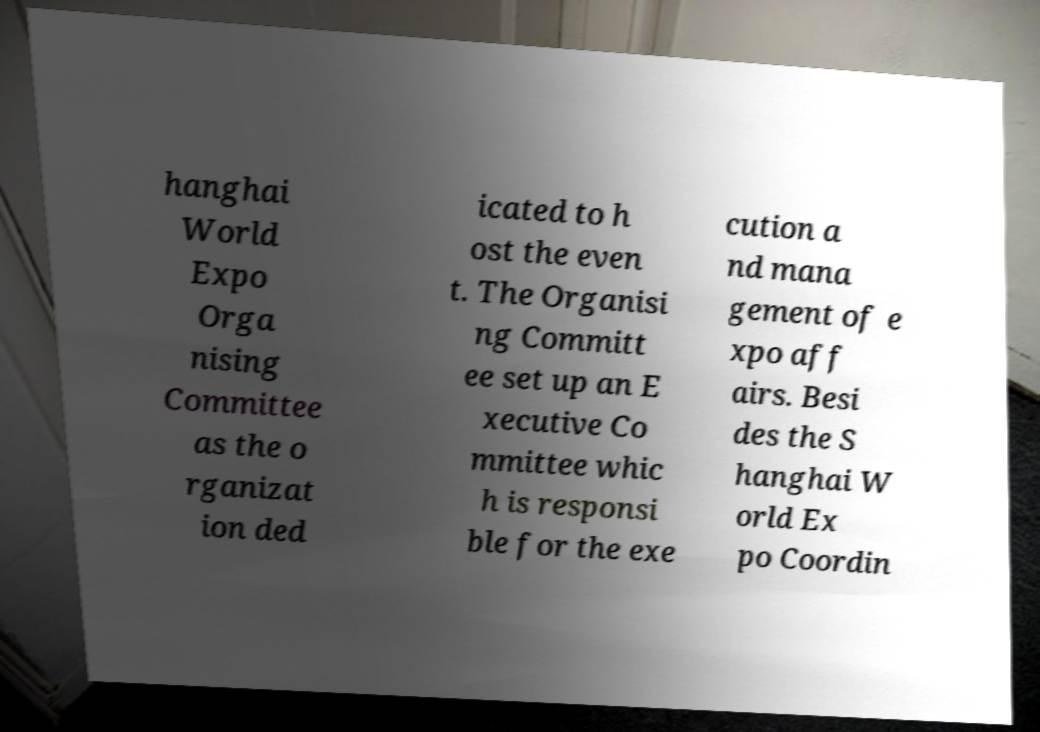Can you accurately transcribe the text from the provided image for me? hanghai World Expo Orga nising Committee as the o rganizat ion ded icated to h ost the even t. The Organisi ng Committ ee set up an E xecutive Co mmittee whic h is responsi ble for the exe cution a nd mana gement of e xpo aff airs. Besi des the S hanghai W orld Ex po Coordin 